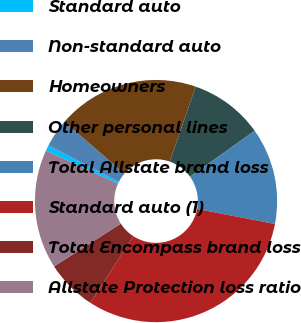Convert chart to OTSL. <chart><loc_0><loc_0><loc_500><loc_500><pie_chart><fcel>Standard auto<fcel>Non-standard auto<fcel>Homeowners<fcel>Other personal lines<fcel>Total Allstate brand loss<fcel>Standard auto (1)<fcel>Total Encompass brand loss<fcel>Allstate Protection loss ratio<nl><fcel>0.74%<fcel>3.77%<fcel>18.95%<fcel>9.84%<fcel>12.88%<fcel>31.09%<fcel>6.81%<fcel>15.91%<nl></chart> 